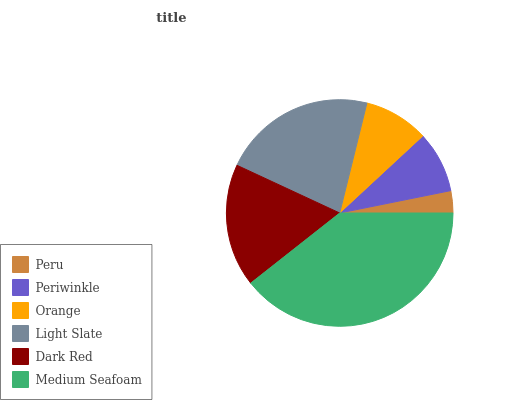Is Peru the minimum?
Answer yes or no. Yes. Is Medium Seafoam the maximum?
Answer yes or no. Yes. Is Periwinkle the minimum?
Answer yes or no. No. Is Periwinkle the maximum?
Answer yes or no. No. Is Periwinkle greater than Peru?
Answer yes or no. Yes. Is Peru less than Periwinkle?
Answer yes or no. Yes. Is Peru greater than Periwinkle?
Answer yes or no. No. Is Periwinkle less than Peru?
Answer yes or no. No. Is Dark Red the high median?
Answer yes or no. Yes. Is Orange the low median?
Answer yes or no. Yes. Is Light Slate the high median?
Answer yes or no. No. Is Medium Seafoam the low median?
Answer yes or no. No. 